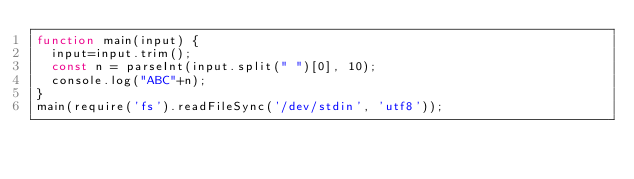<code> <loc_0><loc_0><loc_500><loc_500><_JavaScript_>function main(input) {
  input=input.trim();
  const n = parseInt(input.split(" ")[0], 10);
  console.log("ABC"+n);
}
main(require('fs').readFileSync('/dev/stdin', 'utf8'));</code> 